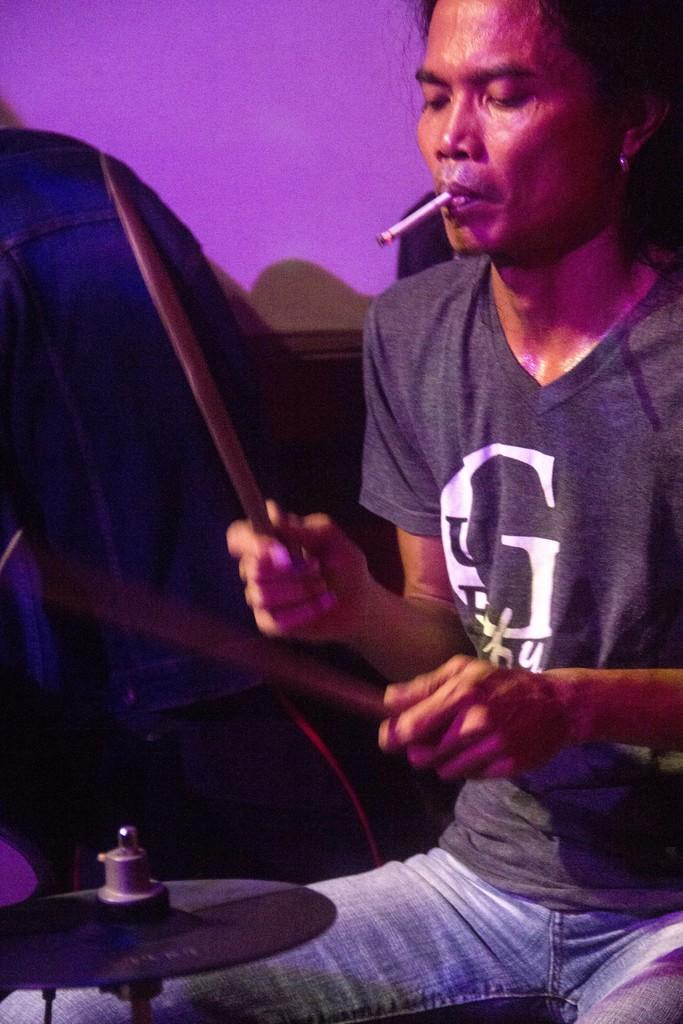<image>
Write a terse but informative summary of the picture. a person with drum sticks wears a shirt with a G on it 